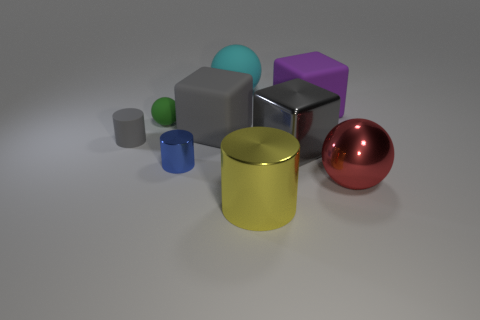Subtract all tiny blue metal cylinders. How many cylinders are left? 2 Subtract 2 cylinders. How many cylinders are left? 1 Subtract all yellow cylinders. How many cylinders are left? 2 Subtract 1 purple cubes. How many objects are left? 8 Subtract all cylinders. How many objects are left? 6 Subtract all brown cubes. Subtract all yellow spheres. How many cubes are left? 3 Subtract all brown cubes. How many gray cylinders are left? 1 Subtract all small blue metal objects. Subtract all shiny objects. How many objects are left? 4 Add 4 blue things. How many blue things are left? 5 Add 7 small red cubes. How many small red cubes exist? 7 